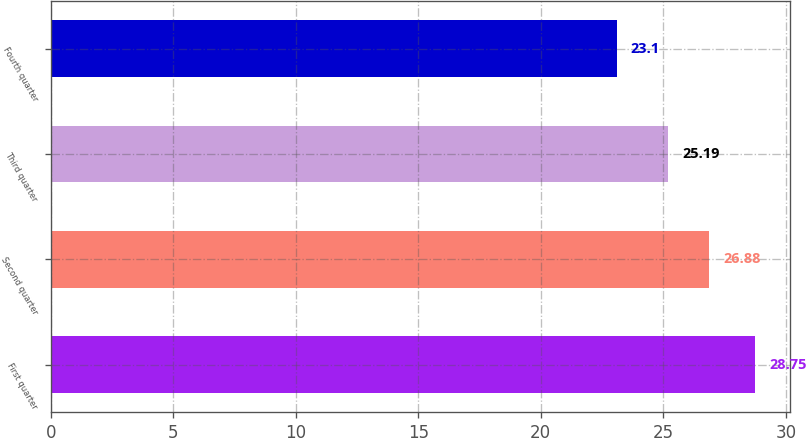Convert chart to OTSL. <chart><loc_0><loc_0><loc_500><loc_500><bar_chart><fcel>First quarter<fcel>Second quarter<fcel>Third quarter<fcel>Fourth quarter<nl><fcel>28.75<fcel>26.88<fcel>25.19<fcel>23.1<nl></chart> 